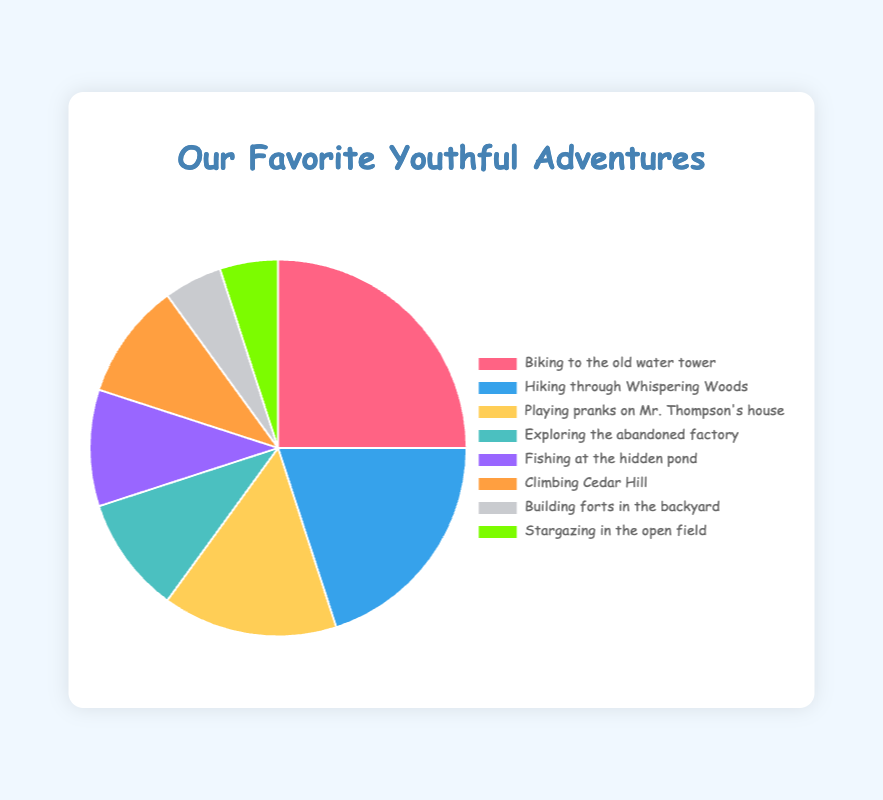What's the most popular activity depicted in the pie chart? The largest segment of the pie chart corresponds to the activity "Biking to the old water tower", with a percentage of 25%.
Answer: Biking to the old water tower What is the total percentage of activities related to being outdoors (biking, hiking, climbing)? Combine the percentages of "Biking to the old water tower" (25%), "Hiking through Whispering Woods" (20%), and "Climbing Cedar Hill" (10%). So, 25% + 20% + 10% = 55%.
Answer: 55% How many activities have an equal percentage, and what is that percentage? The data shows three activities each with a percentage of 10%: "Exploring the abandoned factory", "Fishing at the hidden pond", and "Climbing Cedar Hill".
Answer: Three activities at 10% Which activity has the smallest share in the pie chart, and what is its percentage? The smallest segments correlate to "Building forts in the backyard" and "Stargazing in the open field", each taking up 5% of the pie chart.
Answer: Building forts in the backyard and Stargazing in the open field What is the difference in percentage points between "Biking to the old water tower" and "Playing pranks on Mr. Thompson's house"? Subtract the percentage of "Playing pranks on Mr. Thompson's house" (15%) from the percentage of "Biking to the old water tower" (25%). So, 25 - 15 = 10 percentage points.
Answer: 10 percentage points Which activities share the same color in the pie chart? From the visual, each activity appears to have a distinct color, indicating that no activities share the same color.
Answer: None How does the size of the segment for "Fishing at the hidden pond" visually compare to "Biking to the old water tower"? The segment for "Fishing at the hidden pond" (10%) is visually smaller than the segment for "Biking to the old water tower" (25%). The size is less than half of the latter.
Answer: Smaller What is the total percentage of activities that each take up less than or equal to 15% of the pie chart? Sum the percentages of "Playing pranks on Mr. Thompson's house" (15%), "Exploring the abandoned factory" (10%), "Fishing at the hidden pond" (10%), "Climbing Cedar Hill" (10%), "Building forts in the backyard" (5%), and "Stargazing in the open field" (5%). So, 15% + 10% + 10% + 10% + 5% + 5% = 55%.
Answer: 55% If the activities were ranked from the most to the least favorite, what would be the rank of "Hiking through Whispering Woods"? "Hiking through Whispering Woods" with 20% is the second largest segment in the pie chart.
Answer: 2nd 